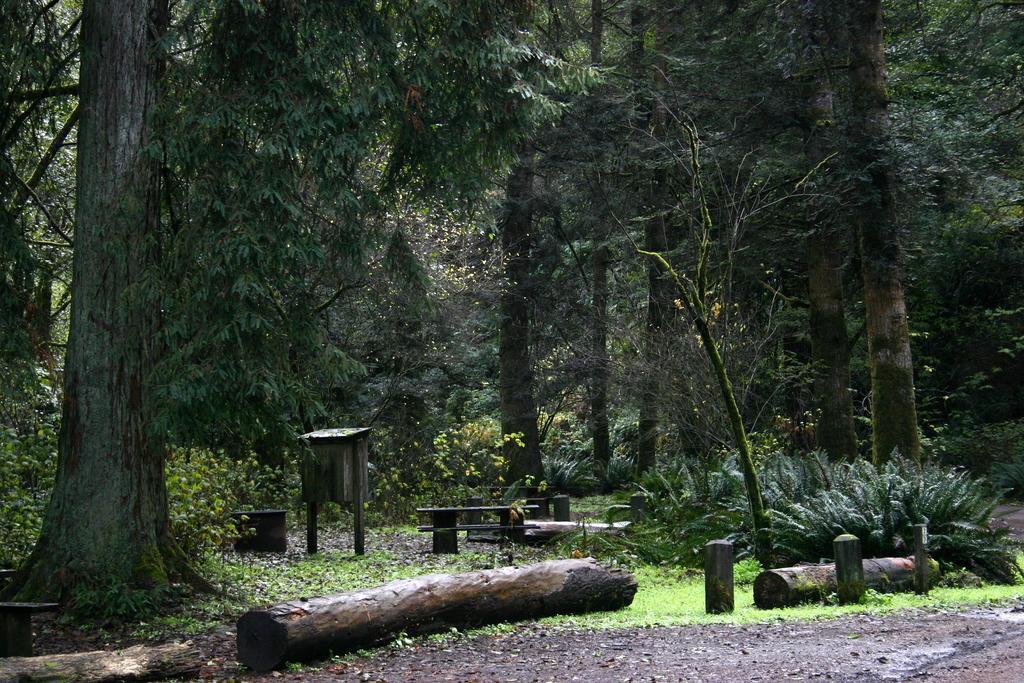Could you give a brief overview of what you see in this image? In the foreground of the picture there are dry leaves, mud, wooden logs and grass. In the middle of the picture there are plants, trees, dry leaves and some wooden objects. In the background there are trees. 